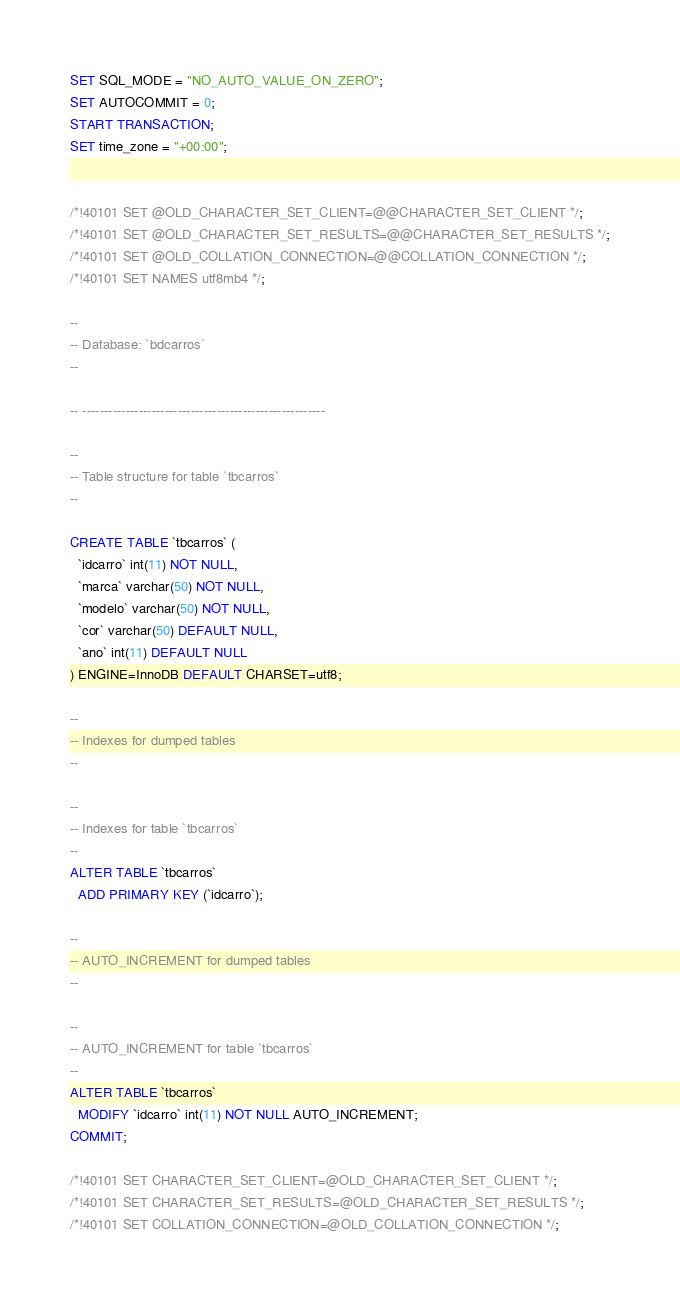<code> <loc_0><loc_0><loc_500><loc_500><_SQL_>SET SQL_MODE = "NO_AUTO_VALUE_ON_ZERO";
SET AUTOCOMMIT = 0;
START TRANSACTION;
SET time_zone = "+00:00";


/*!40101 SET @OLD_CHARACTER_SET_CLIENT=@@CHARACTER_SET_CLIENT */;
/*!40101 SET @OLD_CHARACTER_SET_RESULTS=@@CHARACTER_SET_RESULTS */;
/*!40101 SET @OLD_COLLATION_CONNECTION=@@COLLATION_CONNECTION */;
/*!40101 SET NAMES utf8mb4 */;

--
-- Database: `bdcarros`
--

-- --------------------------------------------------------

--
-- Table structure for table `tbcarros`
--

CREATE TABLE `tbcarros` (
  `idcarro` int(11) NOT NULL,
  `marca` varchar(50) NOT NULL,
  `modelo` varchar(50) NOT NULL,
  `cor` varchar(50) DEFAULT NULL,
  `ano` int(11) DEFAULT NULL
) ENGINE=InnoDB DEFAULT CHARSET=utf8;

--
-- Indexes for dumped tables
--

--
-- Indexes for table `tbcarros`
--
ALTER TABLE `tbcarros`
  ADD PRIMARY KEY (`idcarro`);

--
-- AUTO_INCREMENT for dumped tables
--

--
-- AUTO_INCREMENT for table `tbcarros`
--
ALTER TABLE `tbcarros`
  MODIFY `idcarro` int(11) NOT NULL AUTO_INCREMENT;
COMMIT;

/*!40101 SET CHARACTER_SET_CLIENT=@OLD_CHARACTER_SET_CLIENT */;
/*!40101 SET CHARACTER_SET_RESULTS=@OLD_CHARACTER_SET_RESULTS */;
/*!40101 SET COLLATION_CONNECTION=@OLD_COLLATION_CONNECTION */;
</code> 